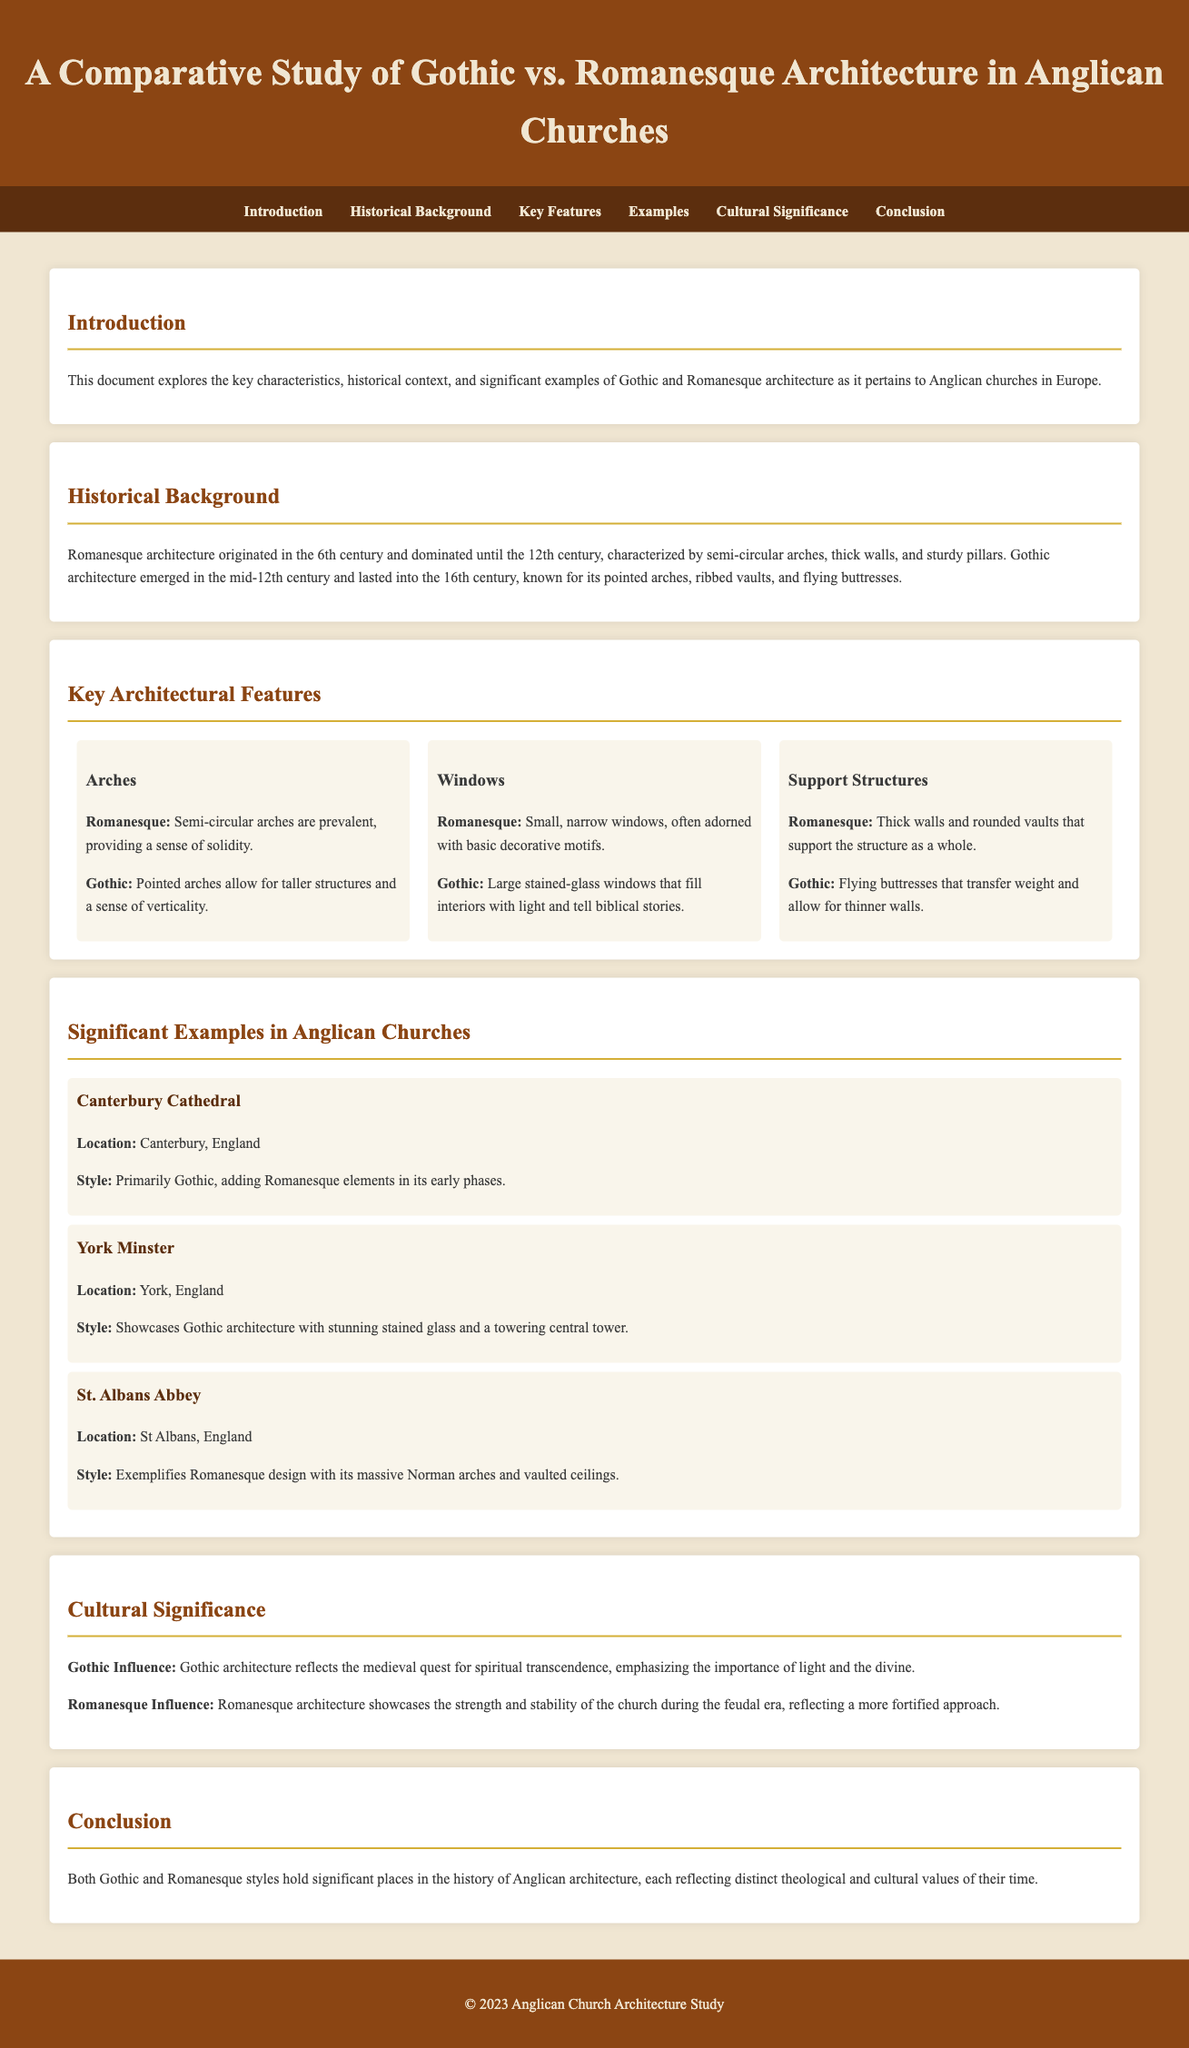What is the primary focus of this document? The document explores the key characteristics, historical context, and significant examples of Gothic and Romanesque architecture in Anglican churches in Europe.
Answer: Gothic and Romanesque architecture When did Romanesque architecture originate? Romanesque architecture originated in the 6th century, as stated in the historical background section of the document.
Answer: 6th century What type of arches are prevalent in Romanesque architecture? The document notes that semi-circular arches are prevalent in Romanesque architecture, providing a sense of solidity.
Answer: Semi-circular arches Which Cathedral is primarily Gothic in style? According to the examples provided, Canterbury Cathedral is primarily Gothic, adding Romanesque elements in its early phases.
Answer: Canterbury Cathedral What is a key characteristic of Gothic windows? The document mentions that Gothic architecture features large stained-glass windows that fill interiors with light and tell biblical stories.
Answer: Large stained-glass windows Which architectural style is exemplified by St. Albans Abbey? St. Albans Abbey is noted in the document as exemplifying Romanesque design due to its massive Norman arches and vaulted ceilings.
Answer: Romanesque design How does Gothic architecture reflect its cultural significance? The cultural significance section highlights that Gothic architecture reflects the medieval quest for spiritual transcendence, emphasizing the importance of light and the divine.
Answer: Spiritual transcendence What architectural feature allows for taller structures in Gothic architecture? The document states that pointed arches allow for taller structures, which is a key feature of Gothic architecture.
Answer: Pointed arches 